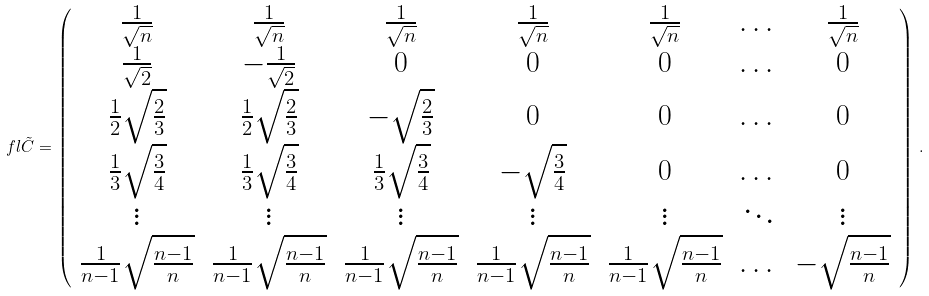<formula> <loc_0><loc_0><loc_500><loc_500>\ f l \tilde { C } = \left ( \begin{array} { c c c c c c c } \frac { 1 } { \sqrt { n } } & \frac { 1 } { \sqrt { n } } & \frac { 1 } { \sqrt { n } } & \frac { 1 } { \sqrt { n } } & \frac { 1 } { \sqrt { n } } & \dots & \frac { 1 } { \sqrt { n } } \\ \frac { 1 } { \sqrt { 2 } } & - \frac { 1 } { \sqrt { 2 } } & 0 & 0 & 0 & \dots & 0 \\ \frac { 1 } { 2 } \sqrt { \frac { 2 } { 3 } } & \frac { 1 } { 2 } \sqrt { \frac { 2 } { 3 } } & - \sqrt { \frac { 2 } { 3 } } & 0 & 0 & \dots & 0 \\ \frac { 1 } { 3 } \sqrt { \frac { 3 } { 4 } } & \frac { 1 } { 3 } \sqrt { \frac { 3 } { 4 } } & \frac { 1 } { 3 } \sqrt { \frac { 3 } { 4 } } & - \sqrt { \frac { 3 } { 4 } } & 0 & \dots & 0 \\ \vdots & \vdots & \vdots & \vdots & \vdots & \ddots & \vdots \\ \frac { 1 } { n - 1 } \sqrt { \frac { n - 1 } { n } } & \frac { 1 } { n - 1 } \sqrt { \frac { n - 1 } { n } } & \frac { 1 } { n - 1 } \sqrt { \frac { n - 1 } { n } } & \frac { 1 } { n - 1 } \sqrt { \frac { n - 1 } { n } } & \frac { 1 } { n - 1 } \sqrt { \frac { n - 1 } { n } } & \dots & - \sqrt { \frac { n - 1 } { n } } \end{array} \right ) \, .</formula> 